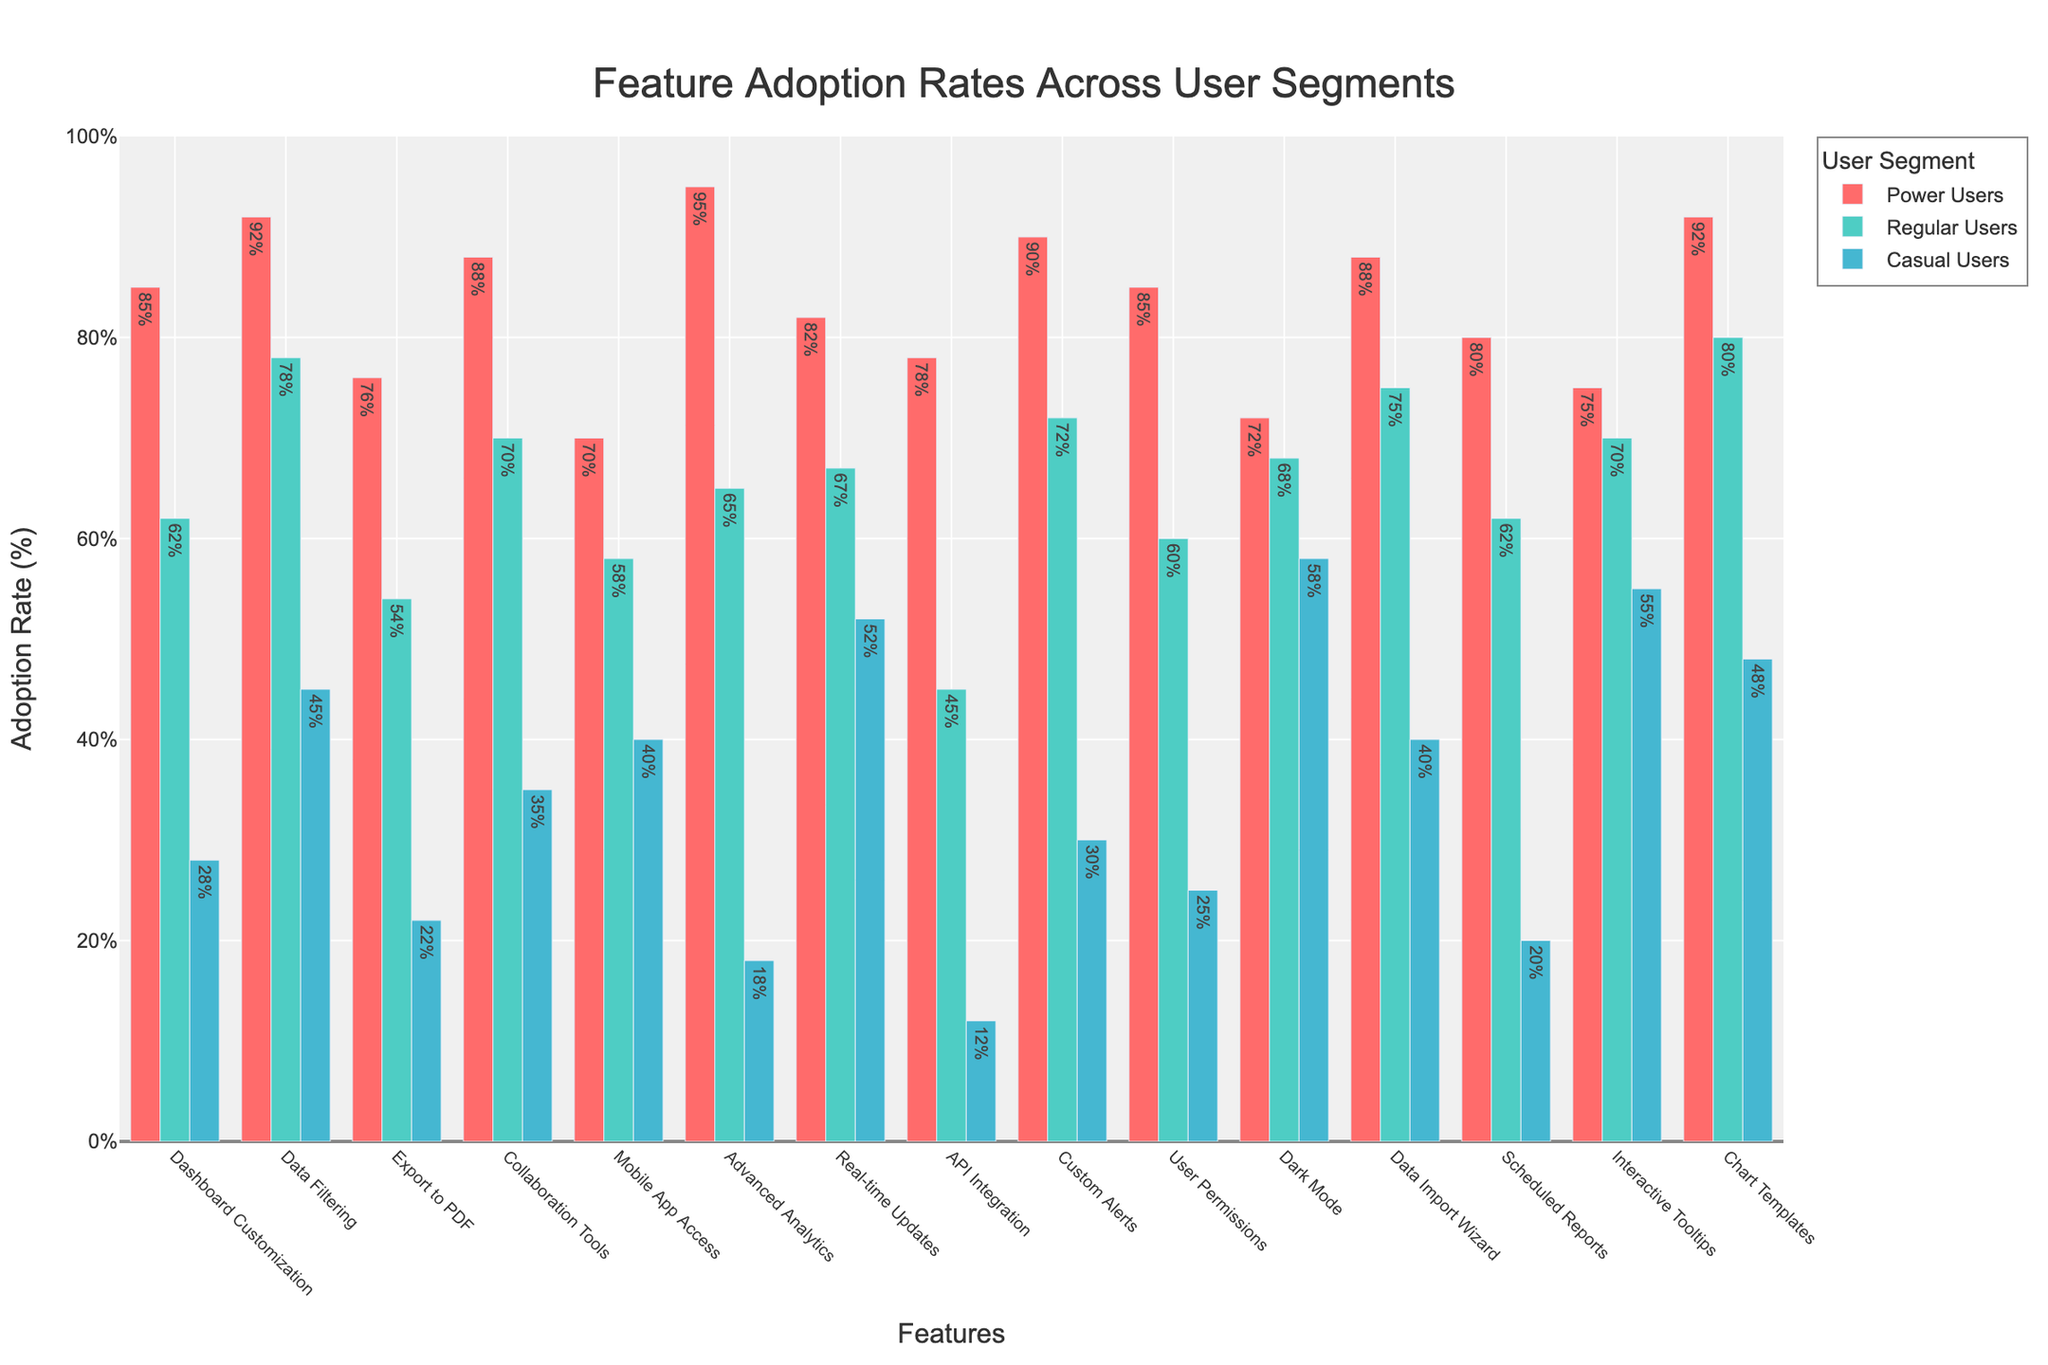What's the total adoption rate for Data Filtering across all user segments? Add the adoption rates of Data Filtering for Power Users (92), Regular Users (78), and Casual Users (45): 92 + 78 + 45 = 215.
Answer: 215% Which user segment has the highest adoption rate for Mobile App Access? Compare the adoption rates of Mobile App Access for Power Users (70), Regular Users (58), and Casual Users (40). The highest rate is for Power Users.
Answer: Power Users How much higher is the adoption rate of Real-time Updates for Power Users compared to Casual Users? Subtract the adoption rate of Real-time Updates for Casual Users (52) from Power Users (82): 82 - 52 = 30.
Answer: 30% Which feature has the smallest adoption rate among all user segments? Look for the smallest value across all bars: API Integration for Casual Users has the smallest adoption rate (12).
Answer: API Integration for Casual Users What's the difference in adoption rates for Collaboration Tools between Power Users and Regular Users? Subtract the adoption rate of Collaboration Tools for Regular Users (70) from Power Users (88): 88 - 70 = 18.
Answer: 18% What is the average adoption rate of Chart Templates across all user segments? Add the adoption rates of Chart Templates for Power Users (92), Regular Users (80), and Casual Users (48), then divide by the number of segments (3): (92 + 80 + 48) / 3 = 220 / 3 ≈ 73.3.
Answer: 73.3% Which feature do Casual Users adopt more than Regular Users? Compare the adoption rates of each feature for Casual Users and Regular Users. Dark Mode (58 vs. 68) is the only feature where Casual Users adopt more.
Answer: Dark Mode Which user segment has the most consistent adoption rate across all features? Look at the adoption rates for each segment and assess the variability: Regular Users' rates are more uniform compared to Power Users and Casual Users.
Answer: Regular Users What is the range of adoption rates for API Integration across all user segments? Subtract the smallest adoption rate of API Integration (Casual Users - 12) from the largest (Power Users - 78): 78 - 12 = 66.
Answer: 66% How many features have an adoption rate greater than 80% for Power Users? Count the number of features where Power Users’ adoption rate exceeds 80%: Dashboard Customization (85), Data Filtering (92), Collaboration Tools (88), Advanced Analytics (95), Real-time Updates (82), Custom Alerts (90), and Chart Templates (92) - 7 features.
Answer: 7 